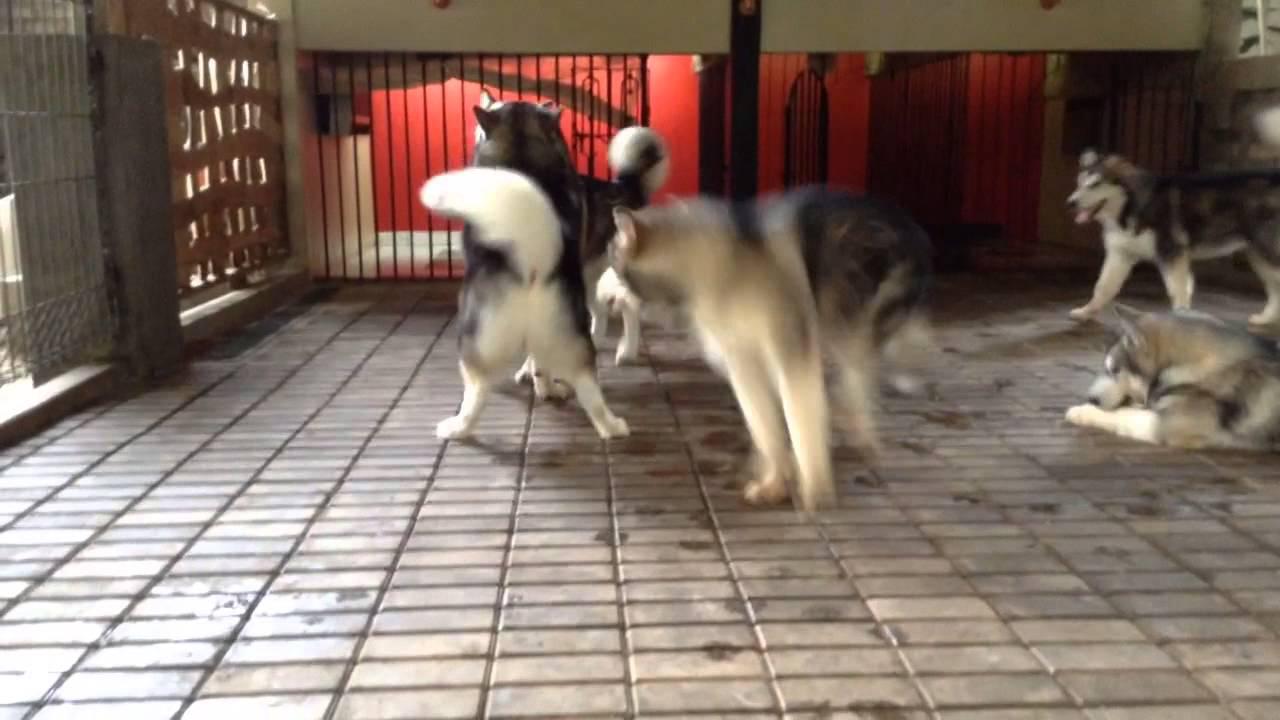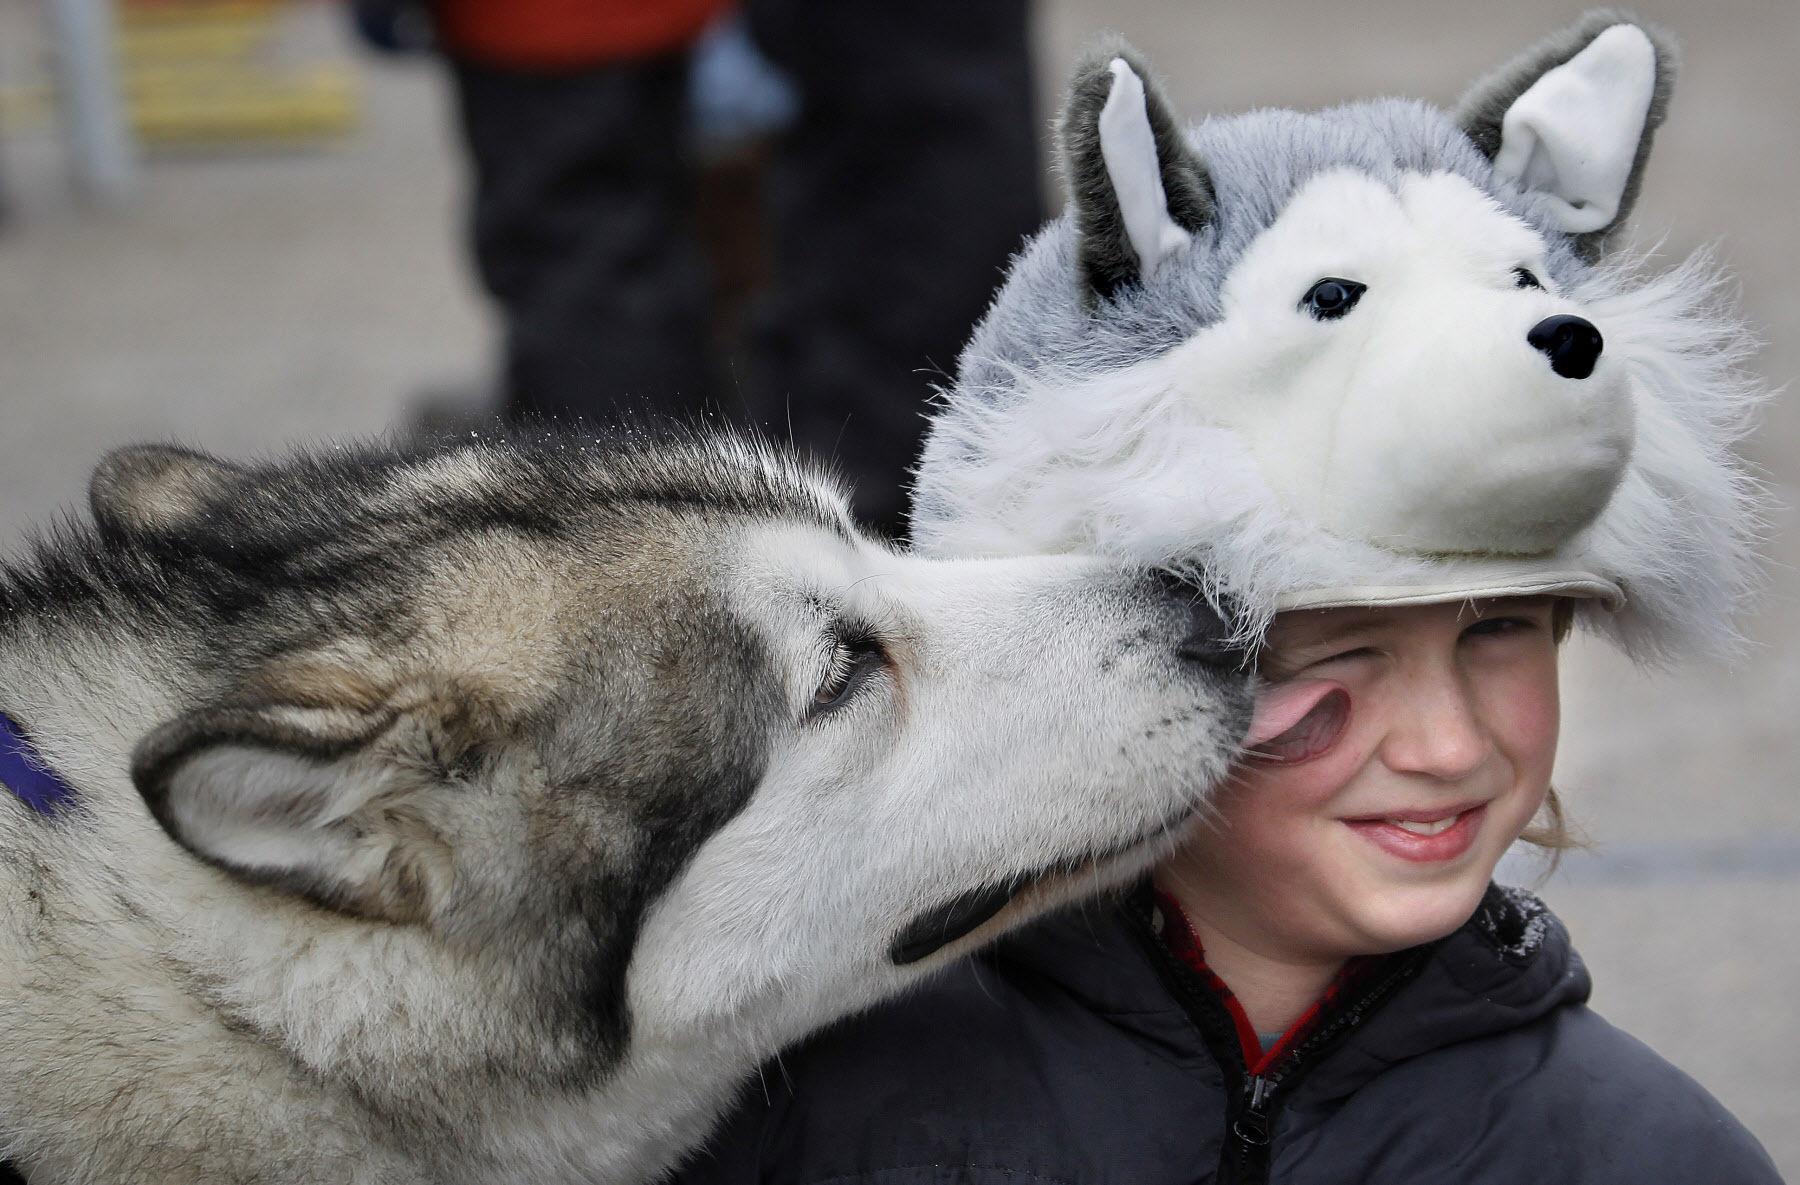The first image is the image on the left, the second image is the image on the right. Assess this claim about the two images: "Two of the huskies are touching faces with each other in snowy weather.". Correct or not? Answer yes or no. No. The first image is the image on the left, the second image is the image on the right. Assess this claim about the two images: "One image shows two 'real' husky dogs posed face-to-face with noses close together and snow on some fur, and the other image includes one dog with its body turned rightward.". Correct or not? Answer yes or no. No. 